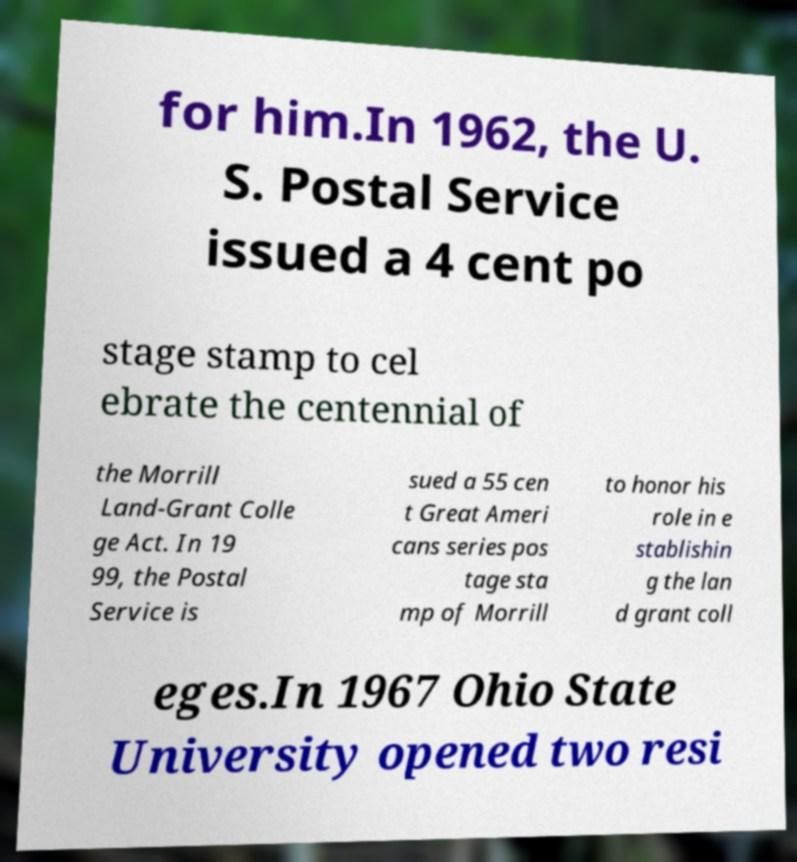Please read and relay the text visible in this image. What does it say? for him.In 1962, the U. S. Postal Service issued a 4 cent po stage stamp to cel ebrate the centennial of the Morrill Land-Grant Colle ge Act. In 19 99, the Postal Service is sued a 55 cen t Great Ameri cans series pos tage sta mp of Morrill to honor his role in e stablishin g the lan d grant coll eges.In 1967 Ohio State University opened two resi 